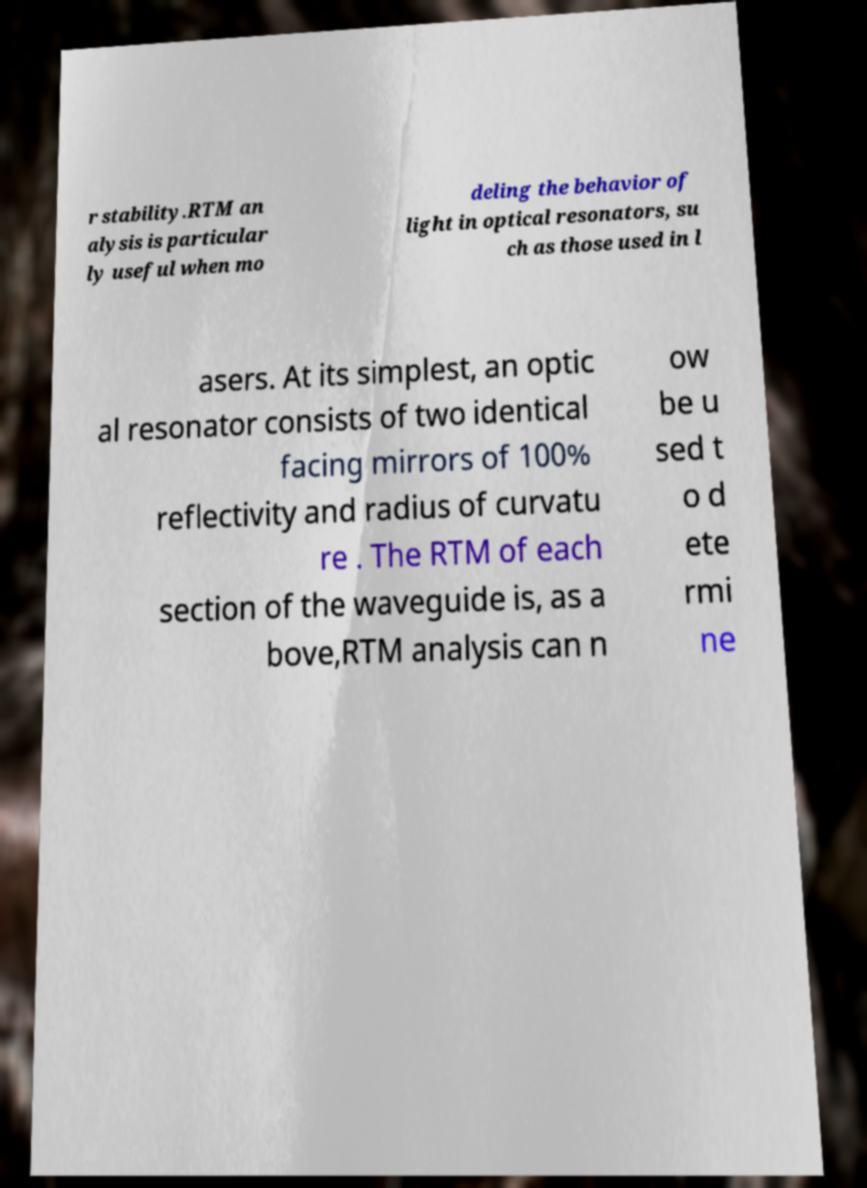I need the written content from this picture converted into text. Can you do that? r stability.RTM an alysis is particular ly useful when mo deling the behavior of light in optical resonators, su ch as those used in l asers. At its simplest, an optic al resonator consists of two identical facing mirrors of 100% reflectivity and radius of curvatu re . The RTM of each section of the waveguide is, as a bove,RTM analysis can n ow be u sed t o d ete rmi ne 